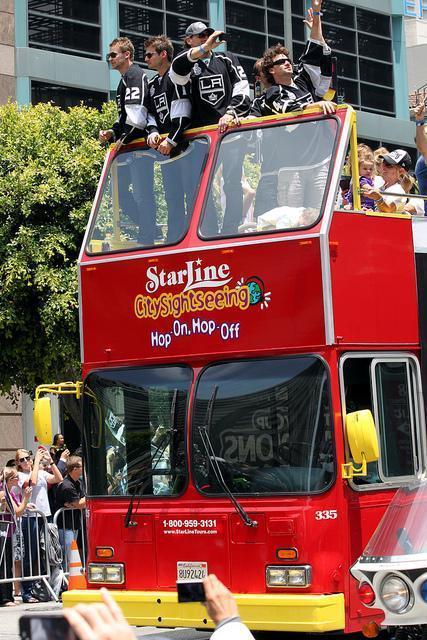How many levels does this bus have?
Give a very brief answer. 2. How many motorcycles can you see?
Give a very brief answer. 1. How many people are in the photo?
Give a very brief answer. 5. 